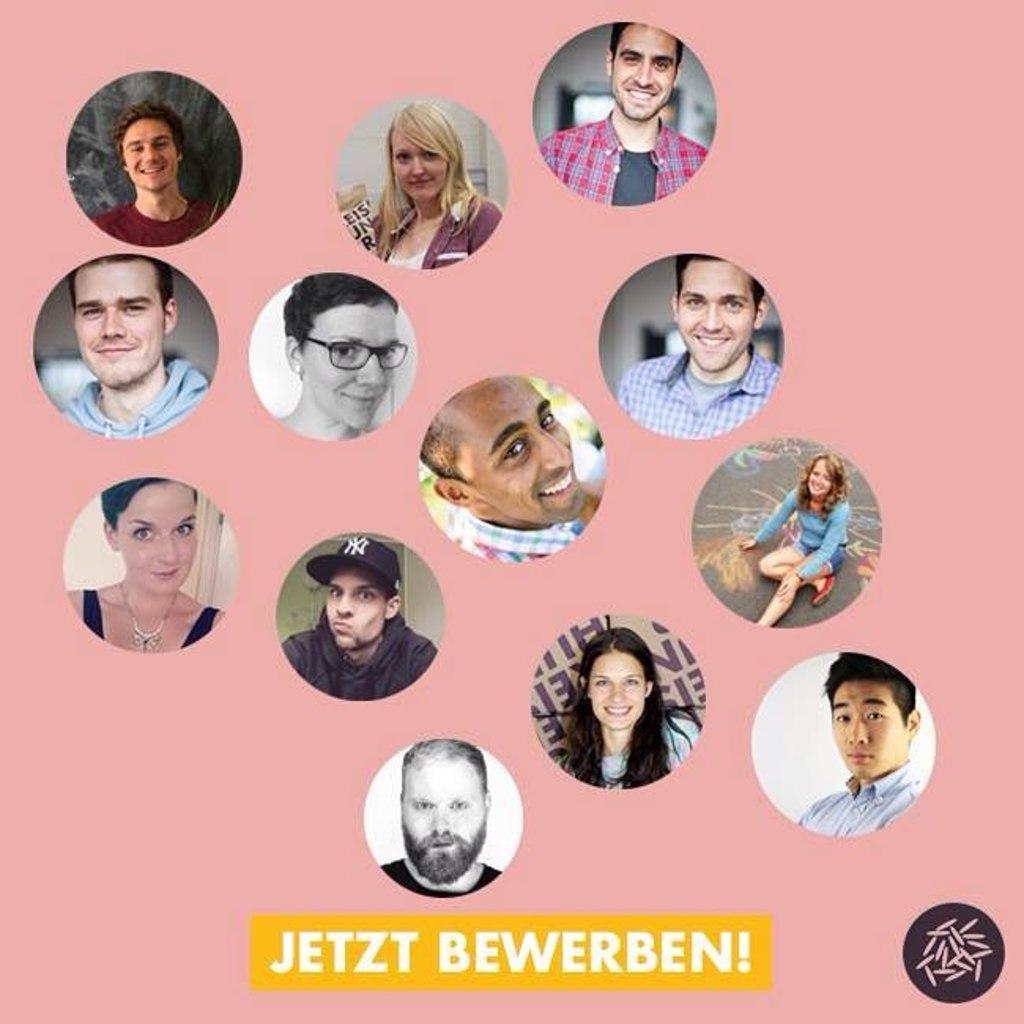Could you give a brief overview of what you see in this image? In this image there are pictures of some people with some text written at the bottom of the image. 